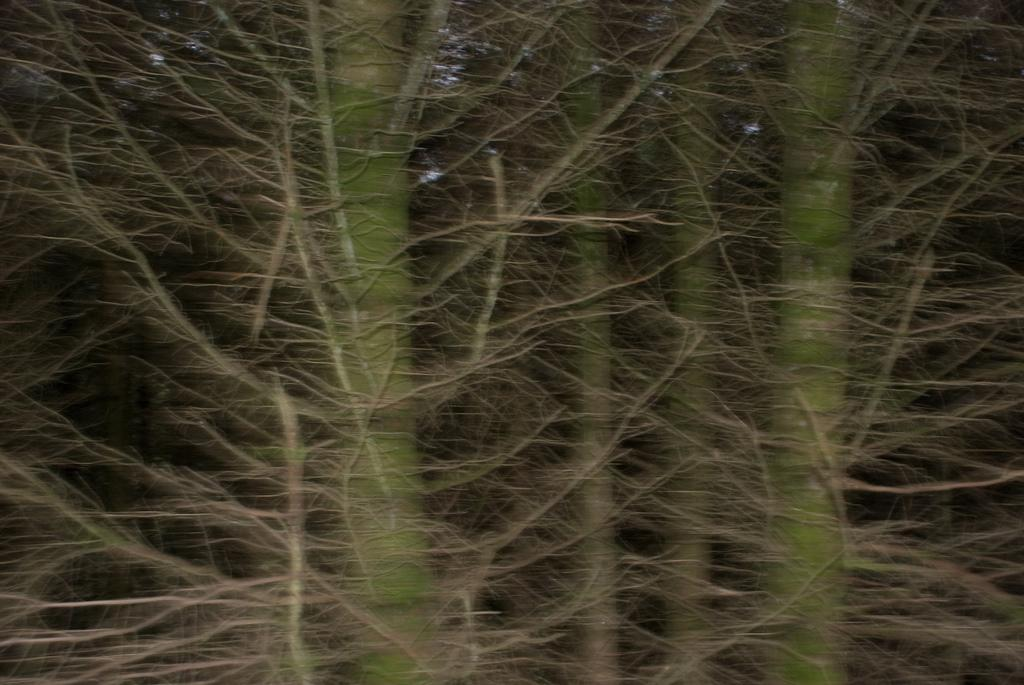What type of vegetation can be seen in the image? There are stems and branches of trees in the image. What color are the trees in the image? The trees in the image are green. What direction are the nerves of the trees growing in the image? There are no nerves present in the image; it features trees with stems and branches. Is there an umbrella visible in the image? There is no umbrella present in the image. 